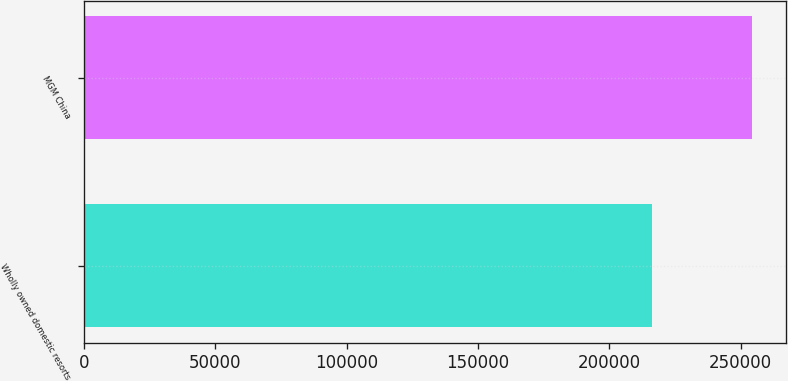Convert chart. <chart><loc_0><loc_0><loc_500><loc_500><bar_chart><fcel>Wholly owned domestic resorts<fcel>MGM China<nl><fcel>216147<fcel>254516<nl></chart> 